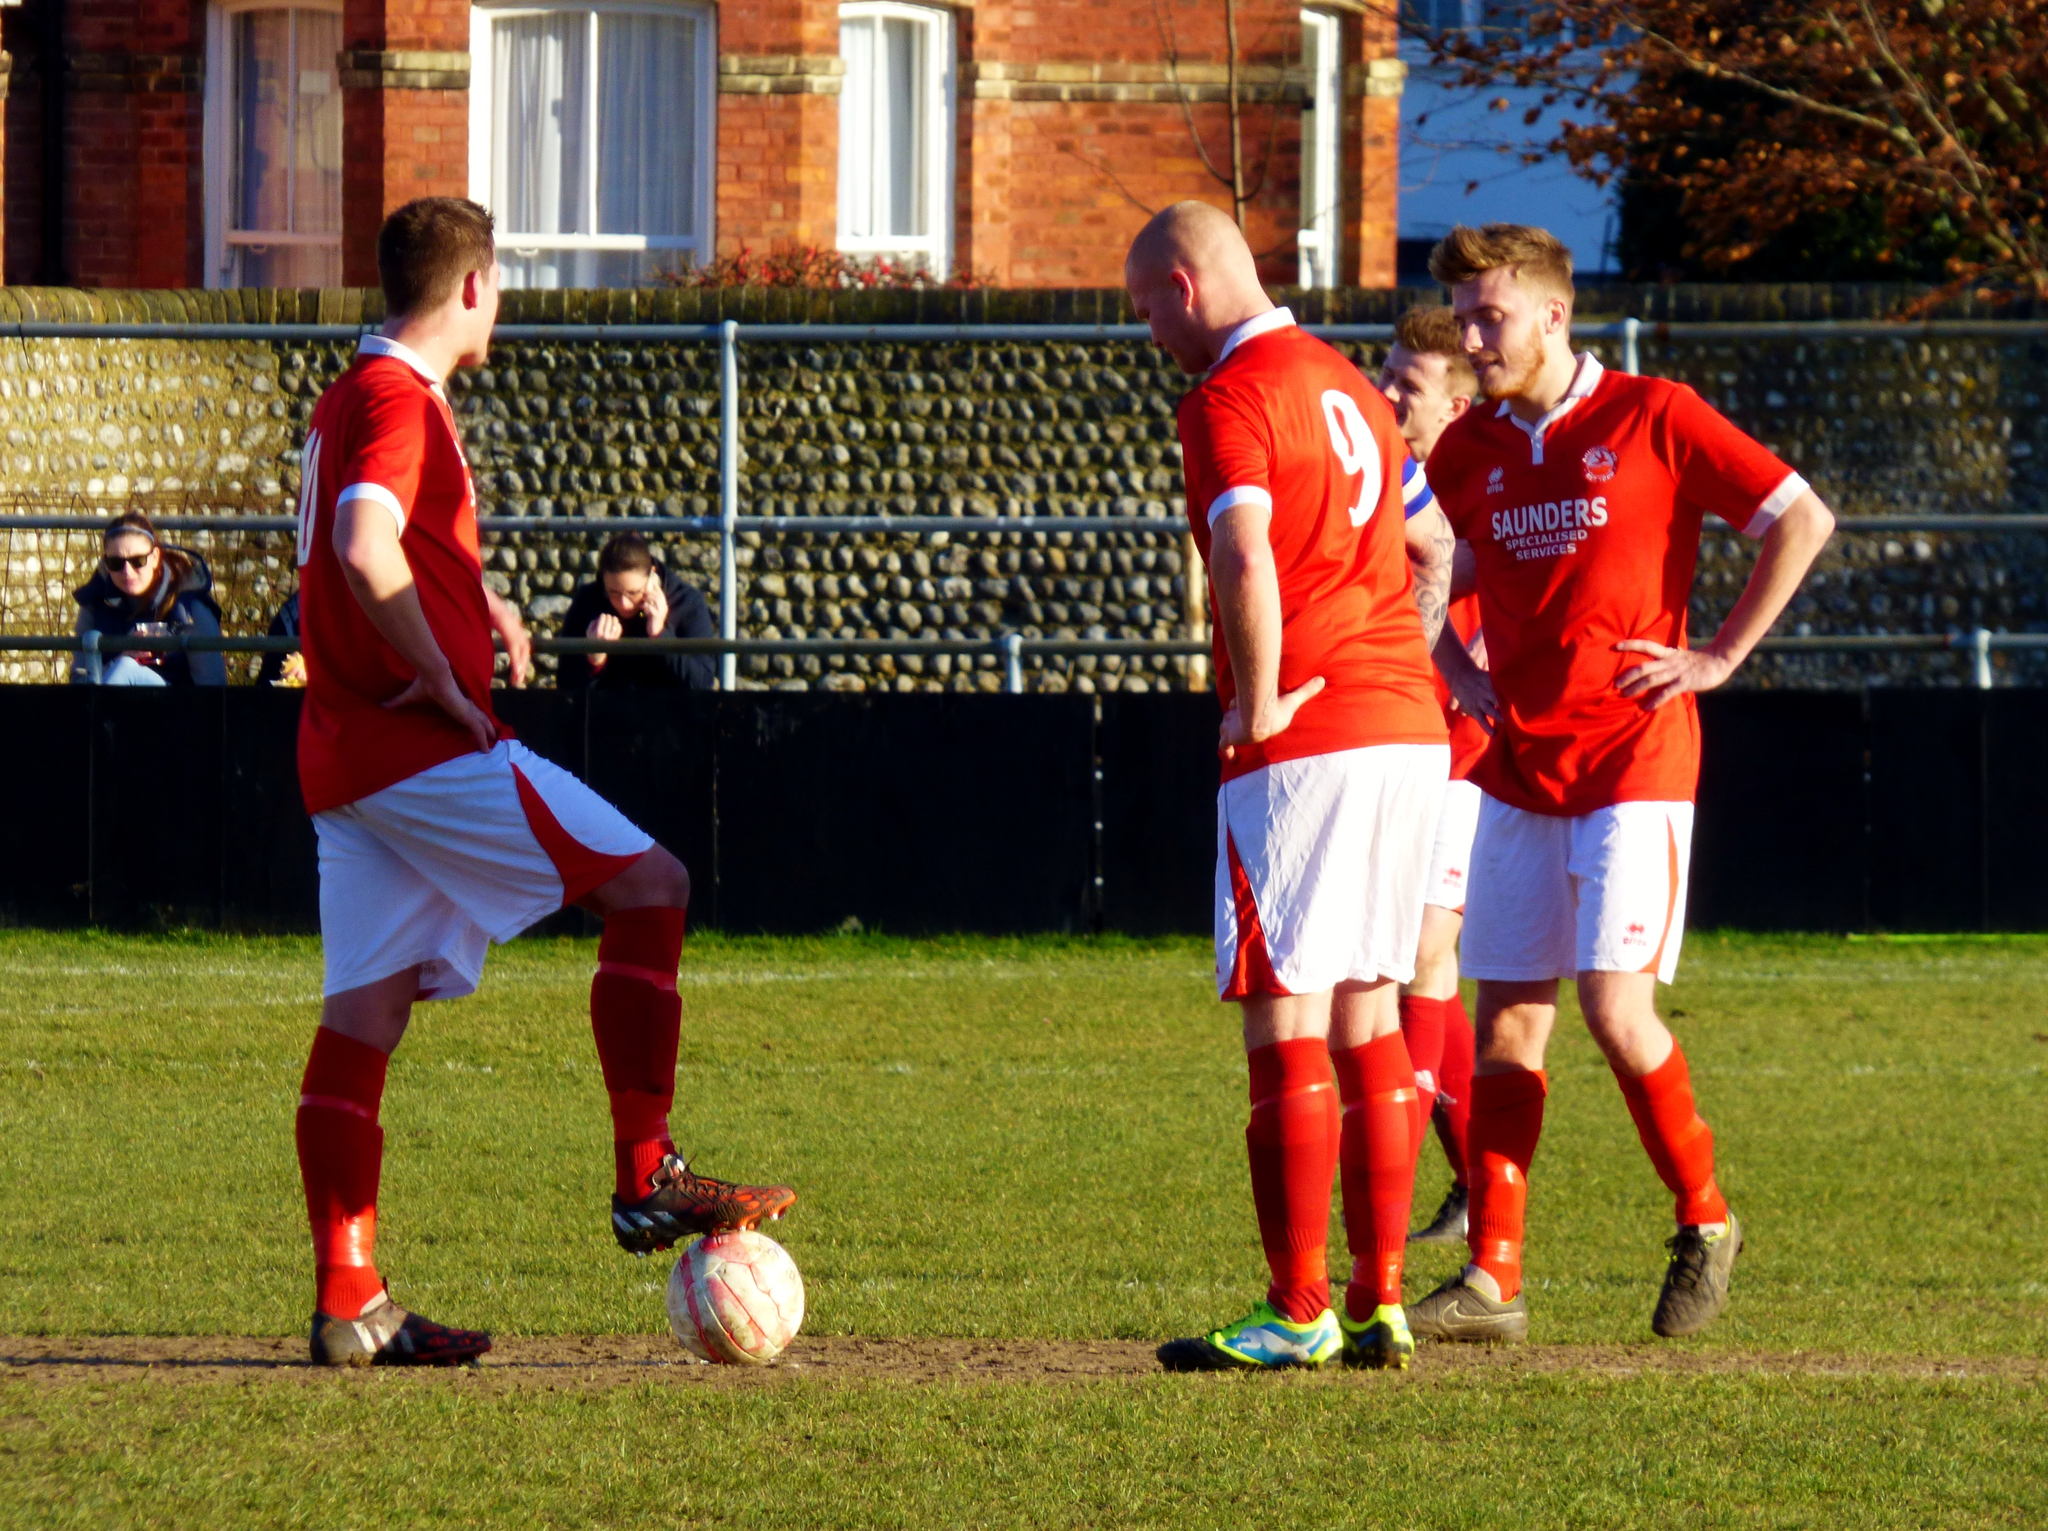<image>
Give a short and clear explanation of the subsequent image. three soccer players wearing red jerseys for saunders specialized services 